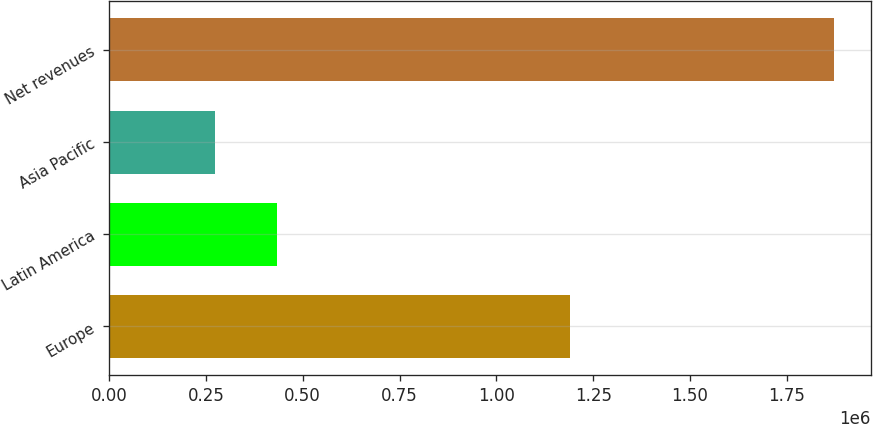<chart> <loc_0><loc_0><loc_500><loc_500><bar_chart><fcel>Europe<fcel>Latin America<fcel>Asia Pacific<fcel>Net revenues<nl><fcel>1.19035e+06<fcel>434726<fcel>274920<fcel>1.87298e+06<nl></chart> 